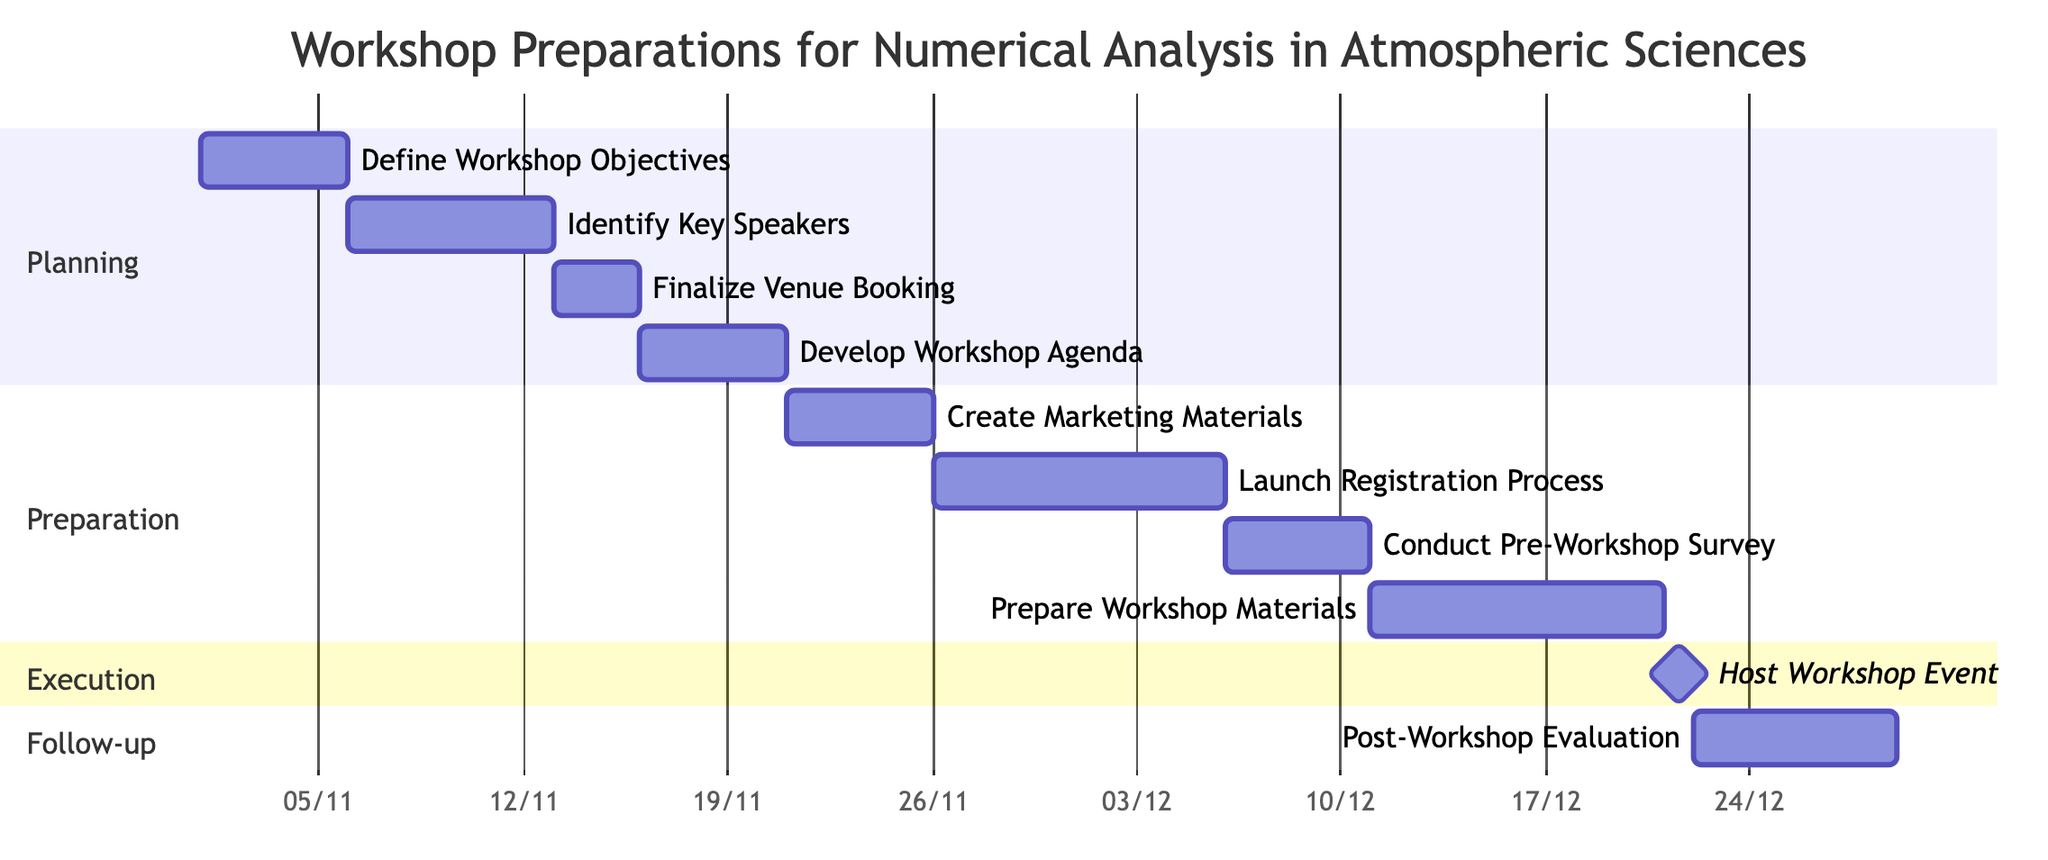What is the duration of the "Define Workshop Objectives" task? The task "Define Workshop Objectives" starts on November 1, 2023, and ends on November 5, 2023. This spans 5 days.
Answer: 5 days Which task follows "Identify Key Speakers"? The "Finalize Venue Booking" task is noted as occurring immediately after "Identify Key Speakers" within the diagram, which confirms it as the next task in the sequence.
Answer: Finalize Venue Booking What is the start date of the "Host Workshop Event"? The "Host Workshop Event" is marked to begin on December 21, 2023, as specified clearly in the diagram.
Answer: December 21, 2023 How many days are allocated for the "Conduct Pre-Workshop Survey"? The "Conduct Pre-Workshop Survey" task starts on December 6, 2023, and ends on December 10, 2023, which is for 5 days in total.
Answer: 5 days What is the sequence of tasks in the Preparation section? The tasks in the Preparation section are "Create Marketing Materials," followed by "Launch Registration Process," then "Conduct Pre-Workshop Survey," and lastly "Prepare Workshop Materials." This sequence reveals the order in which they are organized.
Answer: Create Marketing Materials, Launch Registration Process, Conduct Pre-Workshop Survey, Prepare Workshop Materials What is the relationship between "Finalize Venue Booking" and "Develop Workshop Agenda"? "Finalize Venue Booking" must be completed before the "Develop Workshop Agenda" can begin, as depicted in the diagram, indicating a sequential dependency between the two tasks.
Answer: Sequential dependency How long does the entire workshop preparation process take? The workshop preparation spans from November 1, 2023 (the start of "Define Workshop Objectives") to December 28, 2023 (the end of "Post-Workshop Evaluation"), resulting in a total duration of 58 days.
Answer: 58 days Which task is a milestone in the execution section? The task "Host Workshop Event" is clearly indicated as a milestone within the execution section, signifying its importance in the timeline.
Answer: Host Workshop Event What is the total number of tasks represented in the Gantt chart? The Gantt chart depicts a total of 10 distinct tasks across the different sections, including planning, preparation, execution, and follow-up.
Answer: 10 tasks 